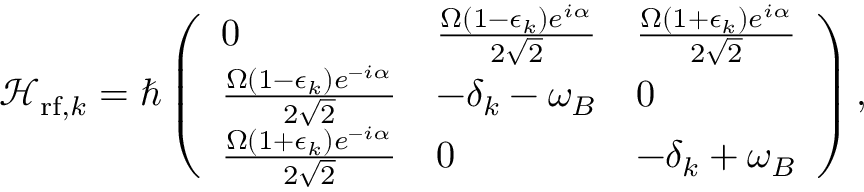Convert formula to latex. <formula><loc_0><loc_0><loc_500><loc_500>\mathcal { H } _ { r f , k } = \hbar { \left } ( \begin{array} { l l l } { 0 } & { \frac { \Omega ( 1 - \epsilon _ { k } ) e ^ { i \alpha } } { 2 \sqrt { 2 } } } & { \frac { \Omega ( 1 + \epsilon _ { k } ) e ^ { i \alpha } } { 2 \sqrt { 2 } } } \\ { \frac { \Omega ( 1 - \epsilon _ { k } ) e ^ { - i \alpha } } { 2 \sqrt { 2 } } } & { - \delta _ { k } - \omega _ { B } } & { 0 } \\ { \frac { \Omega ( 1 + \epsilon _ { k } ) e ^ { - i \alpha } } { 2 \sqrt { 2 } } } & { 0 } & { - \delta _ { k } + \omega _ { B } } \end{array} \right ) ,</formula> 